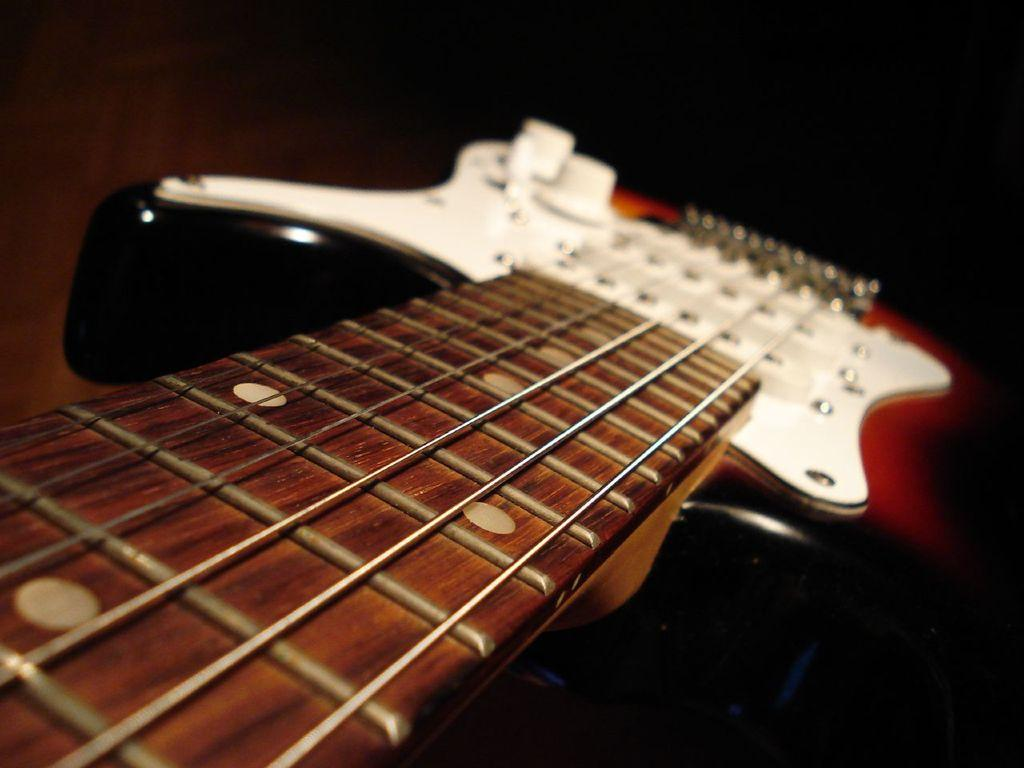What musical instrument is featured in the image? There is a guitar in the image. Can you describe the view of the guitar in the image? The guitar is in a close-up view. What type of toothbrush is shown next to the guitar in the image? There is no toothbrush present in the image; it only features a guitar in a close-up view. 